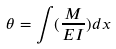<formula> <loc_0><loc_0><loc_500><loc_500>\theta = \int ( \frac { M } { E I } ) d x</formula> 